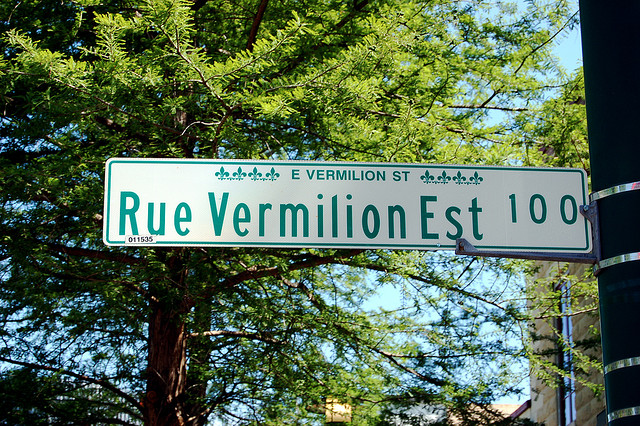Identify and read out the text in this image. VERMILION Vermilion Est Rue 100 ST E 